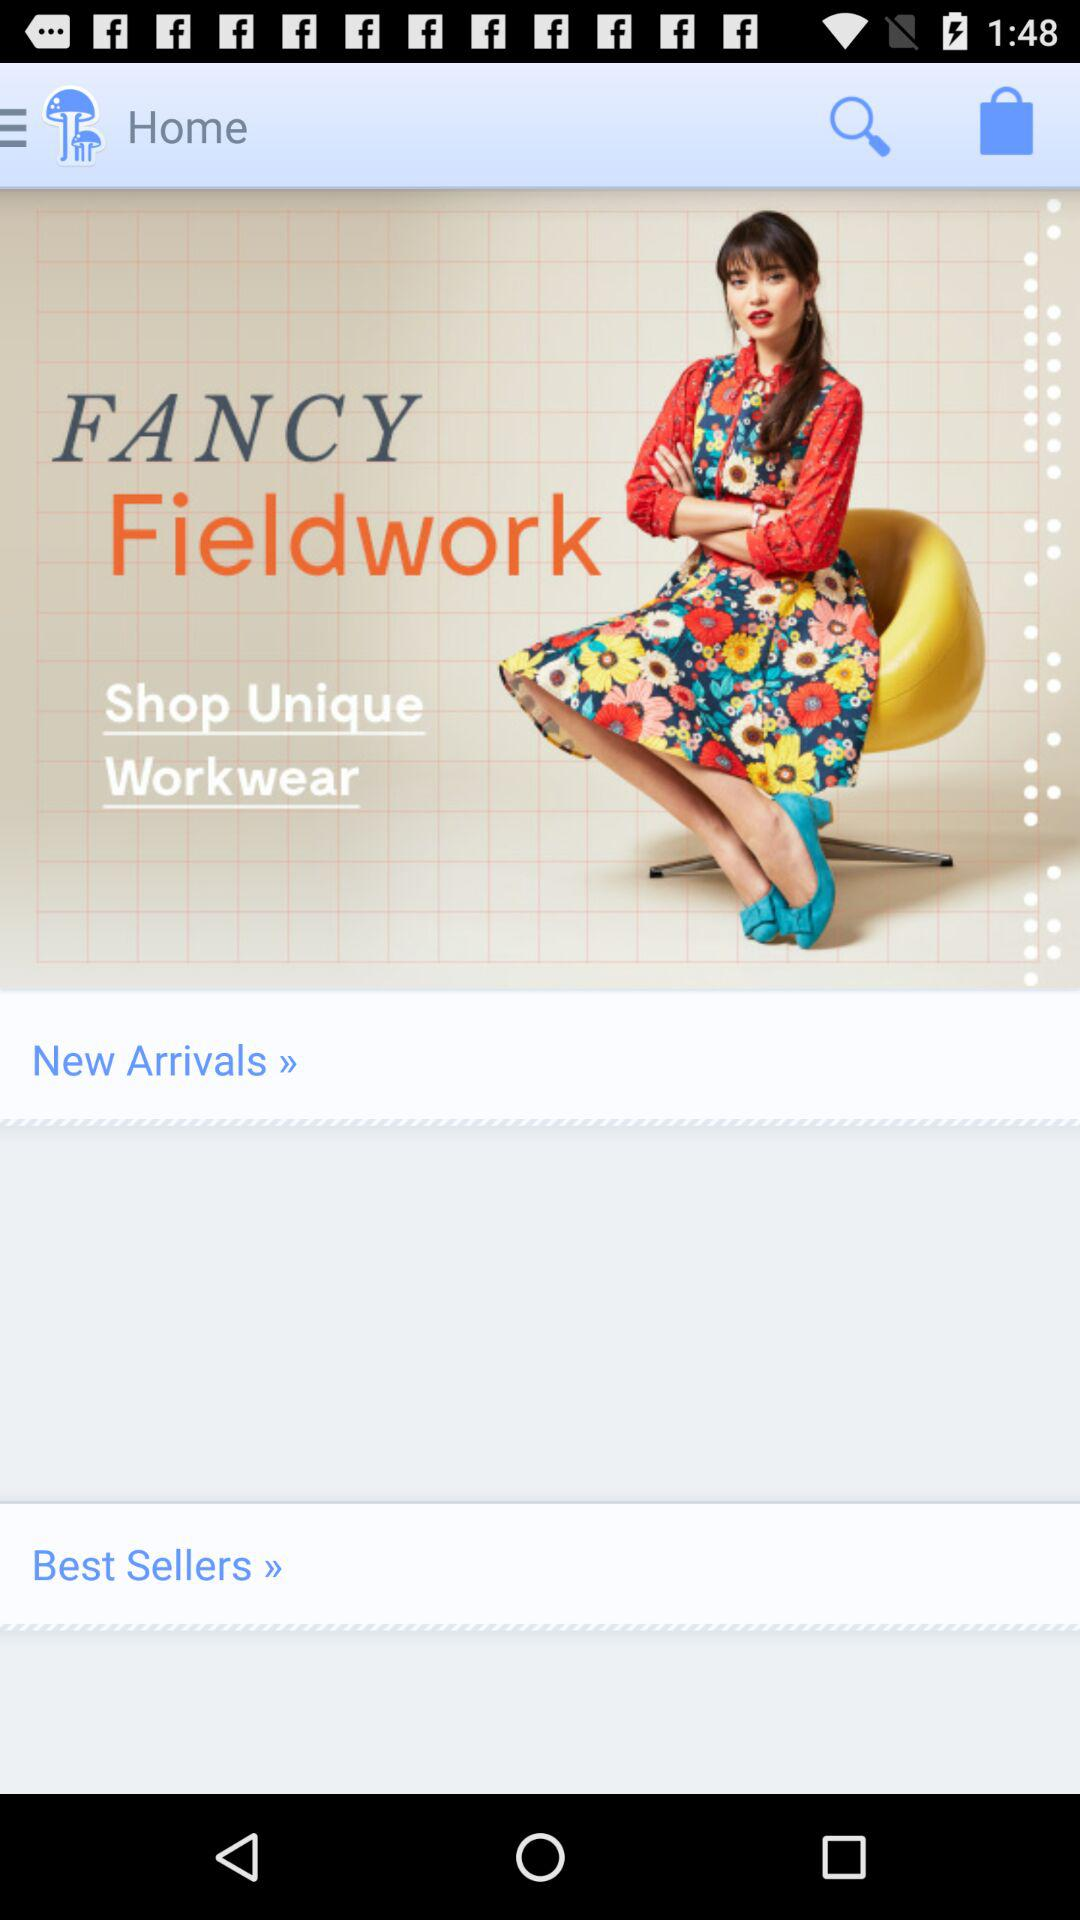What is the application name? The application name is "FANCY Fieldwork". 